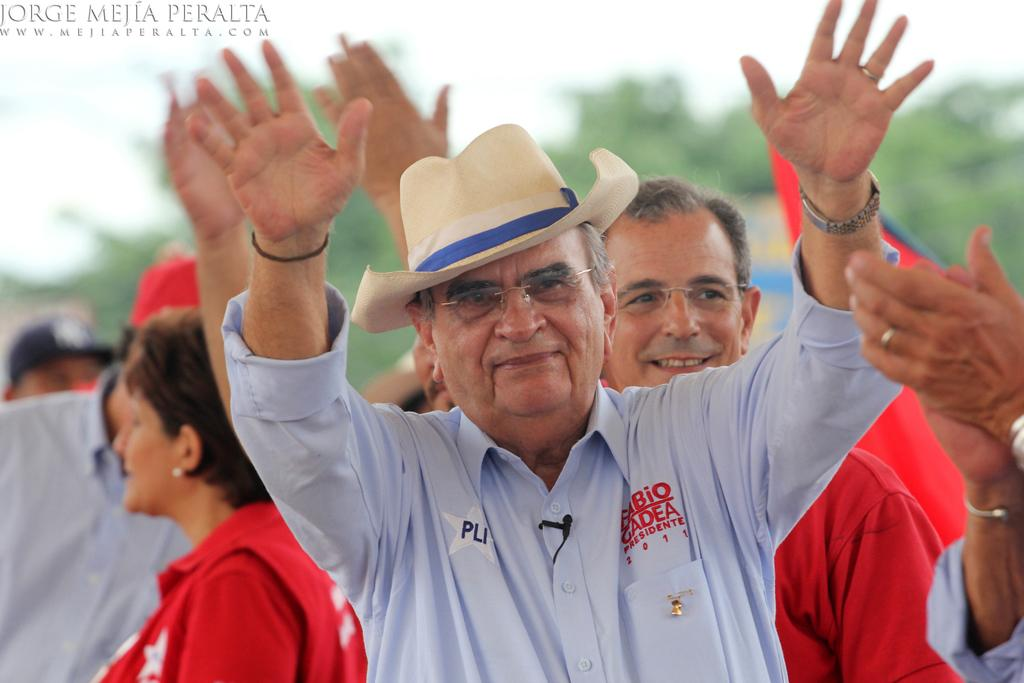What is happening in the image? There are people standing in the image. What can be seen in the background of the image? There are trees in the background of the image. What type of soap is being used by the people in the image? There is no soap present in the image; it only shows people standing and trees in the background. 